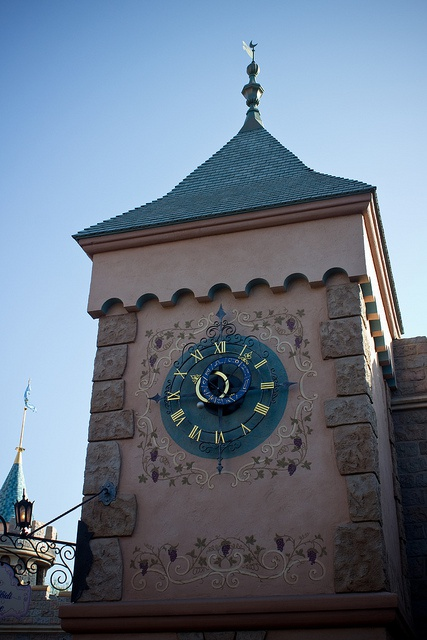Describe the objects in this image and their specific colors. I can see a clock in gray, darkblue, black, and blue tones in this image. 